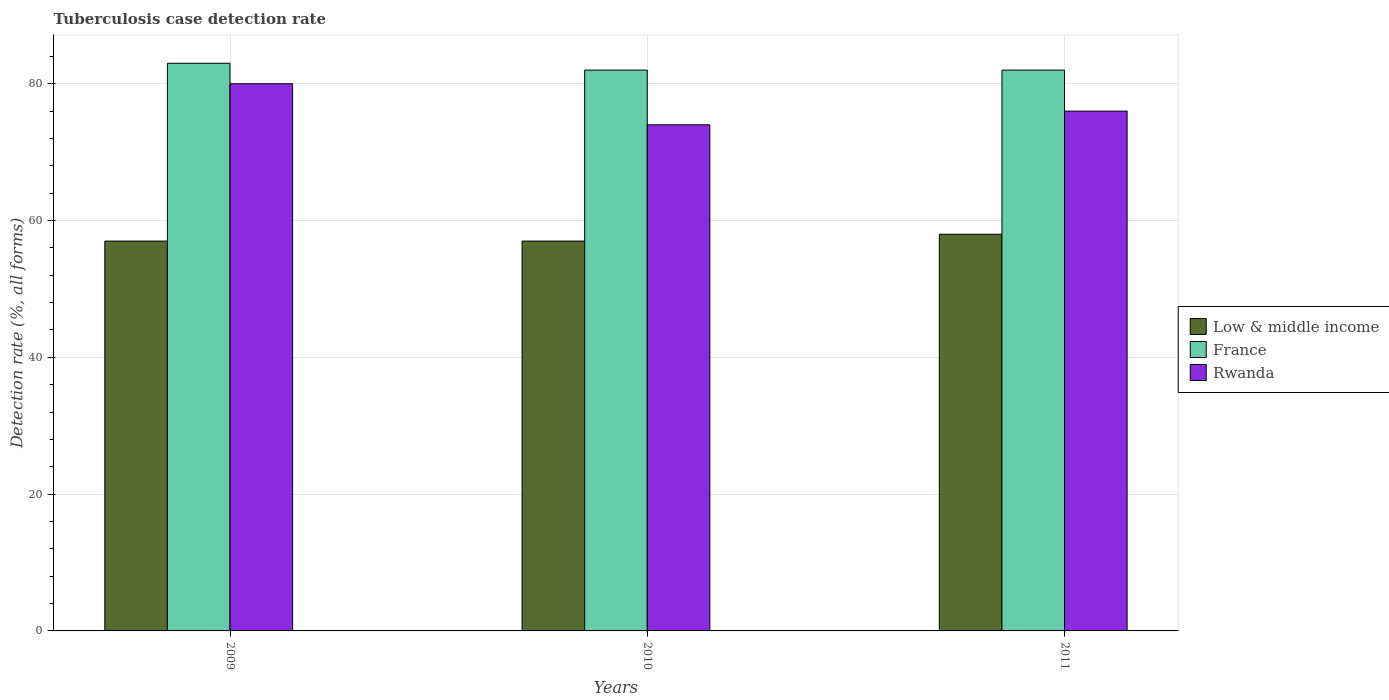How many different coloured bars are there?
Offer a terse response. 3. How many groups of bars are there?
Your answer should be compact. 3. In how many cases, is the number of bars for a given year not equal to the number of legend labels?
Your answer should be very brief. 0. What is the tuberculosis case detection rate in in Rwanda in 2009?
Your response must be concise. 80. Across all years, what is the maximum tuberculosis case detection rate in in Rwanda?
Your answer should be very brief. 80. Across all years, what is the minimum tuberculosis case detection rate in in France?
Your answer should be compact. 82. What is the total tuberculosis case detection rate in in Low & middle income in the graph?
Provide a short and direct response. 172. What is the difference between the tuberculosis case detection rate in in Rwanda in 2009 and that in 2010?
Offer a very short reply. 6. What is the average tuberculosis case detection rate in in Low & middle income per year?
Keep it short and to the point. 57.33. In how many years, is the tuberculosis case detection rate in in Low & middle income greater than 28 %?
Ensure brevity in your answer.  3. What is the ratio of the tuberculosis case detection rate in in France in 2009 to that in 2011?
Ensure brevity in your answer.  1.01. Is the tuberculosis case detection rate in in Low & middle income in 2010 less than that in 2011?
Your answer should be very brief. Yes. Is the difference between the tuberculosis case detection rate in in Rwanda in 2009 and 2010 greater than the difference between the tuberculosis case detection rate in in France in 2009 and 2010?
Give a very brief answer. Yes. What is the difference between the highest and the second highest tuberculosis case detection rate in in France?
Give a very brief answer. 1. What is the difference between the highest and the lowest tuberculosis case detection rate in in Low & middle income?
Your answer should be compact. 1. Is the sum of the tuberculosis case detection rate in in Low & middle income in 2009 and 2010 greater than the maximum tuberculosis case detection rate in in France across all years?
Keep it short and to the point. Yes. What does the 2nd bar from the left in 2009 represents?
Your answer should be compact. France. What does the 1st bar from the right in 2011 represents?
Your response must be concise. Rwanda. How many years are there in the graph?
Offer a terse response. 3. What is the difference between two consecutive major ticks on the Y-axis?
Provide a succinct answer. 20. Does the graph contain grids?
Offer a terse response. Yes. How are the legend labels stacked?
Provide a succinct answer. Vertical. What is the title of the graph?
Offer a terse response. Tuberculosis case detection rate. What is the label or title of the X-axis?
Offer a very short reply. Years. What is the label or title of the Y-axis?
Offer a terse response. Detection rate (%, all forms). What is the Detection rate (%, all forms) of Low & middle income in 2009?
Ensure brevity in your answer.  57. What is the Detection rate (%, all forms) in France in 2009?
Give a very brief answer. 83. What is the Detection rate (%, all forms) of Low & middle income in 2010?
Your response must be concise. 57. What is the Detection rate (%, all forms) of France in 2010?
Offer a terse response. 82. What is the Detection rate (%, all forms) in Low & middle income in 2011?
Your answer should be very brief. 58. What is the Detection rate (%, all forms) in France in 2011?
Keep it short and to the point. 82. Across all years, what is the maximum Detection rate (%, all forms) in Low & middle income?
Ensure brevity in your answer.  58. Across all years, what is the maximum Detection rate (%, all forms) in France?
Your answer should be compact. 83. Across all years, what is the minimum Detection rate (%, all forms) of Low & middle income?
Offer a very short reply. 57. What is the total Detection rate (%, all forms) in Low & middle income in the graph?
Give a very brief answer. 172. What is the total Detection rate (%, all forms) in France in the graph?
Your response must be concise. 247. What is the total Detection rate (%, all forms) in Rwanda in the graph?
Provide a succinct answer. 230. What is the difference between the Detection rate (%, all forms) in France in 2009 and that in 2010?
Offer a terse response. 1. What is the difference between the Detection rate (%, all forms) of Rwanda in 2009 and that in 2010?
Provide a short and direct response. 6. What is the difference between the Detection rate (%, all forms) in Low & middle income in 2009 and that in 2011?
Keep it short and to the point. -1. What is the difference between the Detection rate (%, all forms) in France in 2009 and that in 2011?
Your answer should be very brief. 1. What is the difference between the Detection rate (%, all forms) in Rwanda in 2009 and that in 2011?
Offer a terse response. 4. What is the difference between the Detection rate (%, all forms) in Low & middle income in 2010 and that in 2011?
Your answer should be very brief. -1. What is the difference between the Detection rate (%, all forms) of Rwanda in 2010 and that in 2011?
Offer a very short reply. -2. What is the difference between the Detection rate (%, all forms) in Low & middle income in 2009 and the Detection rate (%, all forms) in Rwanda in 2010?
Provide a short and direct response. -17. What is the difference between the Detection rate (%, all forms) of Low & middle income in 2009 and the Detection rate (%, all forms) of France in 2011?
Give a very brief answer. -25. What is the difference between the Detection rate (%, all forms) in Low & middle income in 2009 and the Detection rate (%, all forms) in Rwanda in 2011?
Provide a succinct answer. -19. What is the difference between the Detection rate (%, all forms) of France in 2009 and the Detection rate (%, all forms) of Rwanda in 2011?
Give a very brief answer. 7. What is the difference between the Detection rate (%, all forms) of Low & middle income in 2010 and the Detection rate (%, all forms) of France in 2011?
Offer a terse response. -25. What is the difference between the Detection rate (%, all forms) of Low & middle income in 2010 and the Detection rate (%, all forms) of Rwanda in 2011?
Provide a succinct answer. -19. What is the average Detection rate (%, all forms) of Low & middle income per year?
Your answer should be very brief. 57.33. What is the average Detection rate (%, all forms) in France per year?
Provide a succinct answer. 82.33. What is the average Detection rate (%, all forms) in Rwanda per year?
Give a very brief answer. 76.67. In the year 2010, what is the difference between the Detection rate (%, all forms) of France and Detection rate (%, all forms) of Rwanda?
Your answer should be compact. 8. In the year 2011, what is the difference between the Detection rate (%, all forms) in Low & middle income and Detection rate (%, all forms) in Rwanda?
Offer a terse response. -18. What is the ratio of the Detection rate (%, all forms) in Low & middle income in 2009 to that in 2010?
Give a very brief answer. 1. What is the ratio of the Detection rate (%, all forms) of France in 2009 to that in 2010?
Your answer should be very brief. 1.01. What is the ratio of the Detection rate (%, all forms) of Rwanda in 2009 to that in 2010?
Ensure brevity in your answer.  1.08. What is the ratio of the Detection rate (%, all forms) in Low & middle income in 2009 to that in 2011?
Your answer should be very brief. 0.98. What is the ratio of the Detection rate (%, all forms) of France in 2009 to that in 2011?
Provide a succinct answer. 1.01. What is the ratio of the Detection rate (%, all forms) in Rwanda in 2009 to that in 2011?
Ensure brevity in your answer.  1.05. What is the ratio of the Detection rate (%, all forms) in Low & middle income in 2010 to that in 2011?
Give a very brief answer. 0.98. What is the ratio of the Detection rate (%, all forms) in Rwanda in 2010 to that in 2011?
Your response must be concise. 0.97. What is the difference between the highest and the second highest Detection rate (%, all forms) of Low & middle income?
Provide a succinct answer. 1. What is the difference between the highest and the second highest Detection rate (%, all forms) in Rwanda?
Your answer should be compact. 4. What is the difference between the highest and the lowest Detection rate (%, all forms) in France?
Provide a short and direct response. 1. 